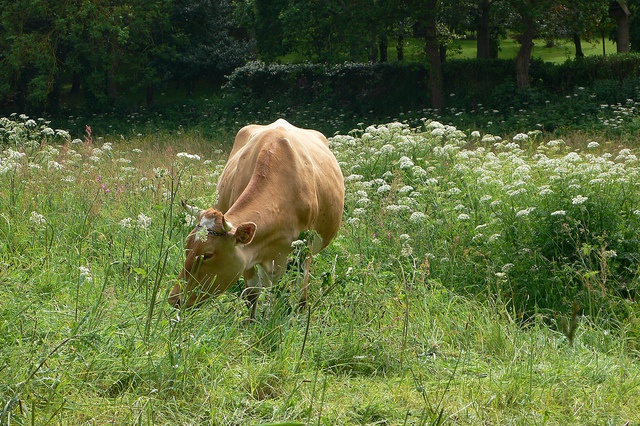Describe the objects in this image and their specific colors. I can see a cow in black, olive, gray, and tan tones in this image. 